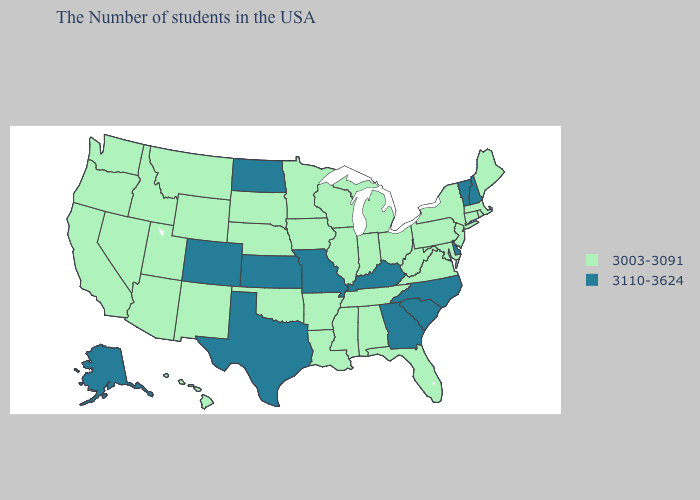Is the legend a continuous bar?
Give a very brief answer. No. Name the states that have a value in the range 3110-3624?
Be succinct. New Hampshire, Vermont, Delaware, North Carolina, South Carolina, Georgia, Kentucky, Missouri, Kansas, Texas, North Dakota, Colorado, Alaska. What is the value of Missouri?
Give a very brief answer. 3110-3624. Does Kansas have the lowest value in the MidWest?
Quick response, please. No. What is the value of New Mexico?
Give a very brief answer. 3003-3091. Which states have the lowest value in the USA?
Quick response, please. Maine, Massachusetts, Rhode Island, Connecticut, New York, New Jersey, Maryland, Pennsylvania, Virginia, West Virginia, Ohio, Florida, Michigan, Indiana, Alabama, Tennessee, Wisconsin, Illinois, Mississippi, Louisiana, Arkansas, Minnesota, Iowa, Nebraska, Oklahoma, South Dakota, Wyoming, New Mexico, Utah, Montana, Arizona, Idaho, Nevada, California, Washington, Oregon, Hawaii. Name the states that have a value in the range 3003-3091?
Keep it brief. Maine, Massachusetts, Rhode Island, Connecticut, New York, New Jersey, Maryland, Pennsylvania, Virginia, West Virginia, Ohio, Florida, Michigan, Indiana, Alabama, Tennessee, Wisconsin, Illinois, Mississippi, Louisiana, Arkansas, Minnesota, Iowa, Nebraska, Oklahoma, South Dakota, Wyoming, New Mexico, Utah, Montana, Arizona, Idaho, Nevada, California, Washington, Oregon, Hawaii. What is the value of Ohio?
Give a very brief answer. 3003-3091. Among the states that border Montana , does North Dakota have the lowest value?
Give a very brief answer. No. Does Florida have the lowest value in the South?
Be succinct. Yes. What is the highest value in states that border Rhode Island?
Give a very brief answer. 3003-3091. Does Alabama have the highest value in the USA?
Answer briefly. No. Does the map have missing data?
Quick response, please. No. Does the first symbol in the legend represent the smallest category?
Short answer required. Yes. Is the legend a continuous bar?
Give a very brief answer. No. 